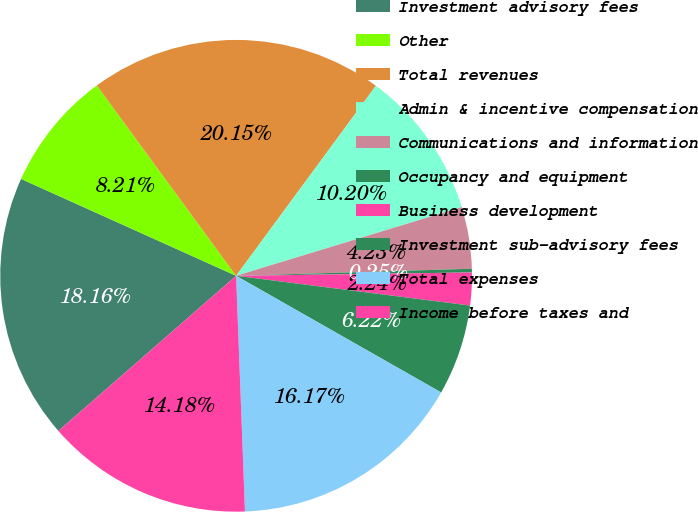Convert chart. <chart><loc_0><loc_0><loc_500><loc_500><pie_chart><fcel>Investment advisory fees<fcel>Other<fcel>Total revenues<fcel>Admin & incentive compensation<fcel>Communications and information<fcel>Occupancy and equipment<fcel>Business development<fcel>Investment sub-advisory fees<fcel>Total expenses<fcel>Income before taxes and<nl><fcel>18.16%<fcel>8.21%<fcel>20.15%<fcel>10.2%<fcel>4.23%<fcel>0.25%<fcel>2.24%<fcel>6.22%<fcel>16.17%<fcel>14.18%<nl></chart> 